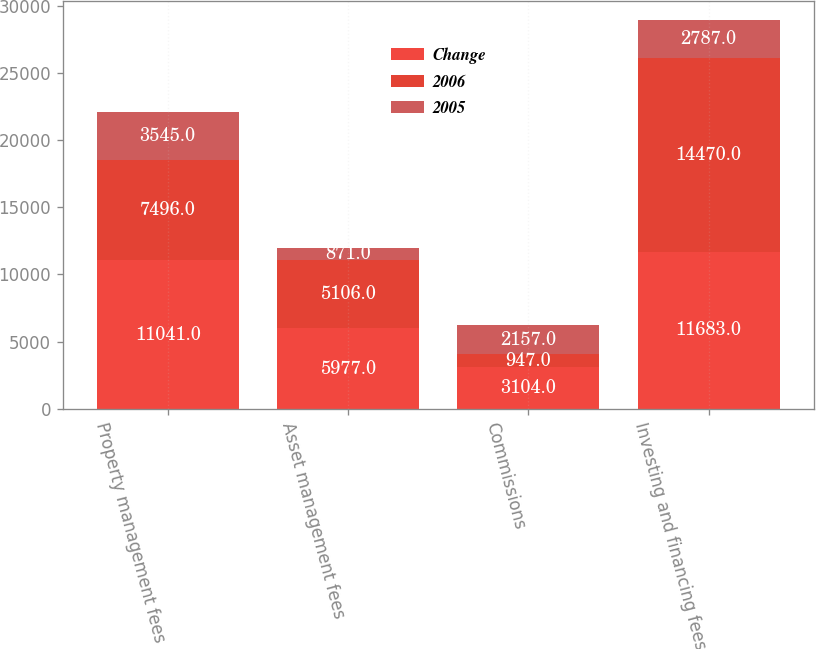Convert chart to OTSL. <chart><loc_0><loc_0><loc_500><loc_500><stacked_bar_chart><ecel><fcel>Property management fees<fcel>Asset management fees<fcel>Commissions<fcel>Investing and financing fees<nl><fcel>Change<fcel>11041<fcel>5977<fcel>3104<fcel>11683<nl><fcel>2006<fcel>7496<fcel>5106<fcel>947<fcel>14470<nl><fcel>2005<fcel>3545<fcel>871<fcel>2157<fcel>2787<nl></chart> 